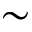<formula> <loc_0><loc_0><loc_500><loc_500>\sim</formula> 